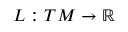<formula> <loc_0><loc_0><loc_500><loc_500>L \colon T M \to \mathbb { R }</formula> 